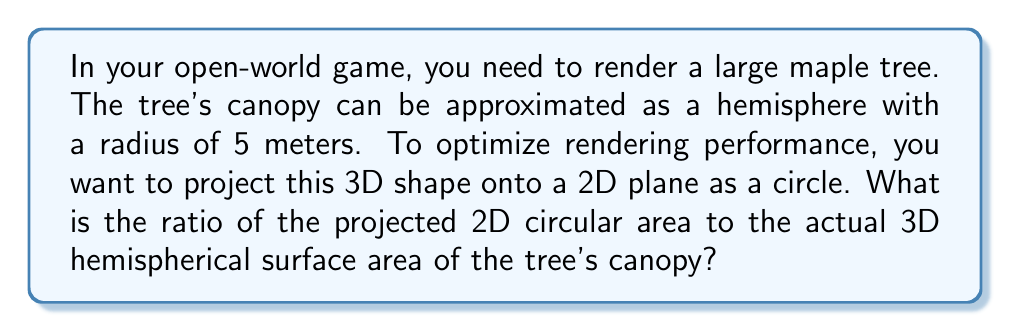Provide a solution to this math problem. Let's approach this step-by-step:

1) First, we need to calculate the surface area of the hemispherical canopy:
   The surface area of a hemisphere is given by the formula:
   $$A_{hemisphere} = 2\pi r^2$$
   Where $r$ is the radius of the hemisphere.
   $$A_{hemisphere} = 2\pi (5^2) = 50\pi \approx 157.08 \text{ m}^2$$

2) Next, we calculate the area of the projected 2D circle:
   The area of a circle is given by the formula:
   $$A_{circle} = \pi r^2$$
   Using the same radius:
   $$A_{circle} = \pi (5^2) = 25\pi \approx 78.54 \text{ m}^2$$

3) Now, we can calculate the ratio of the projected 2D area to the 3D surface area:
   $$\text{Ratio} = \frac{A_{circle}}{A_{hemisphere}} = \frac{25\pi}{50\pi} = \frac{1}{2} = 0.5$$

This means the projected 2D area is exactly half of the actual 3D surface area of the hemispherical canopy.

[asy]
import geometry;

size(200);
real r = 5;
pair O = (0,0);

draw(circle(O, r), rgb(0,0.7,0));
draw(arc(O, r, 180, 360), rgb(0,0.5,0)+1);
draw((-r,0)--(r,0), dashed);

label("r", (r/2,0), S);
label("Projected 2D Circle", (0,-r-1));
label("3D Hemisphere", (0,r/2));
[/asy]
Answer: 0.5 